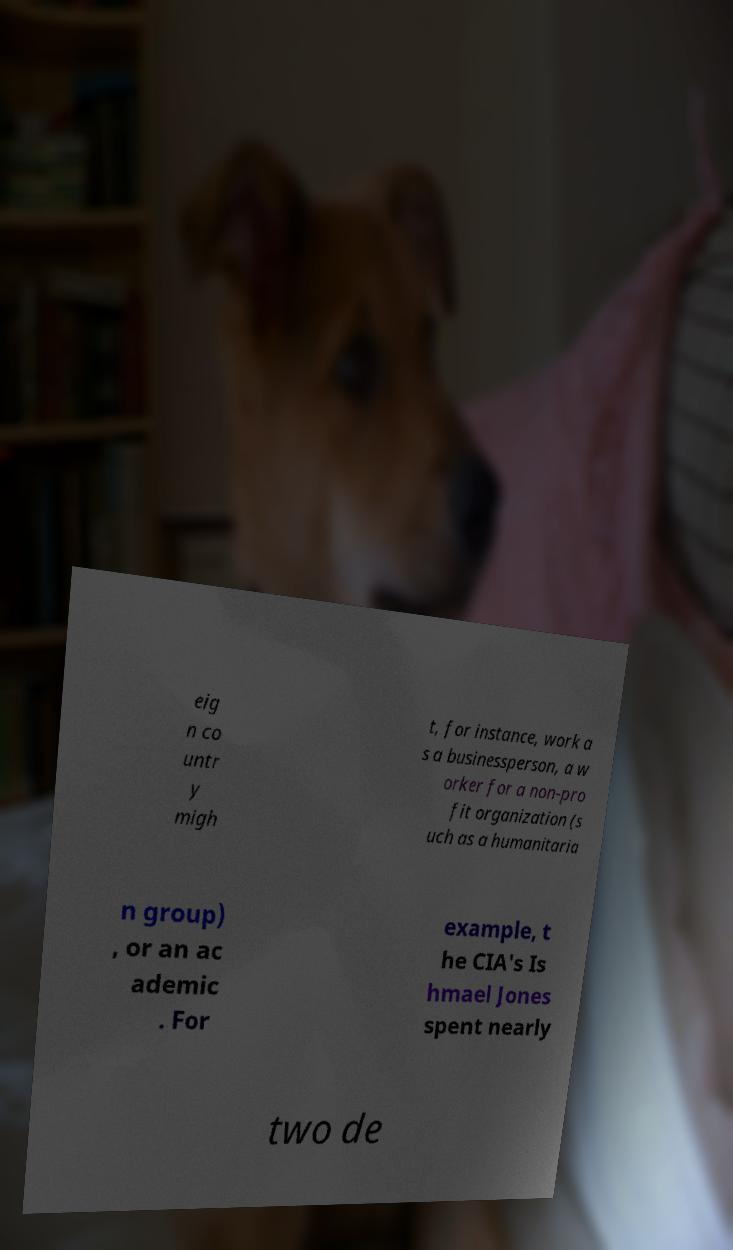Can you accurately transcribe the text from the provided image for me? eig n co untr y migh t, for instance, work a s a businessperson, a w orker for a non-pro fit organization (s uch as a humanitaria n group) , or an ac ademic . For example, t he CIA's Is hmael Jones spent nearly two de 